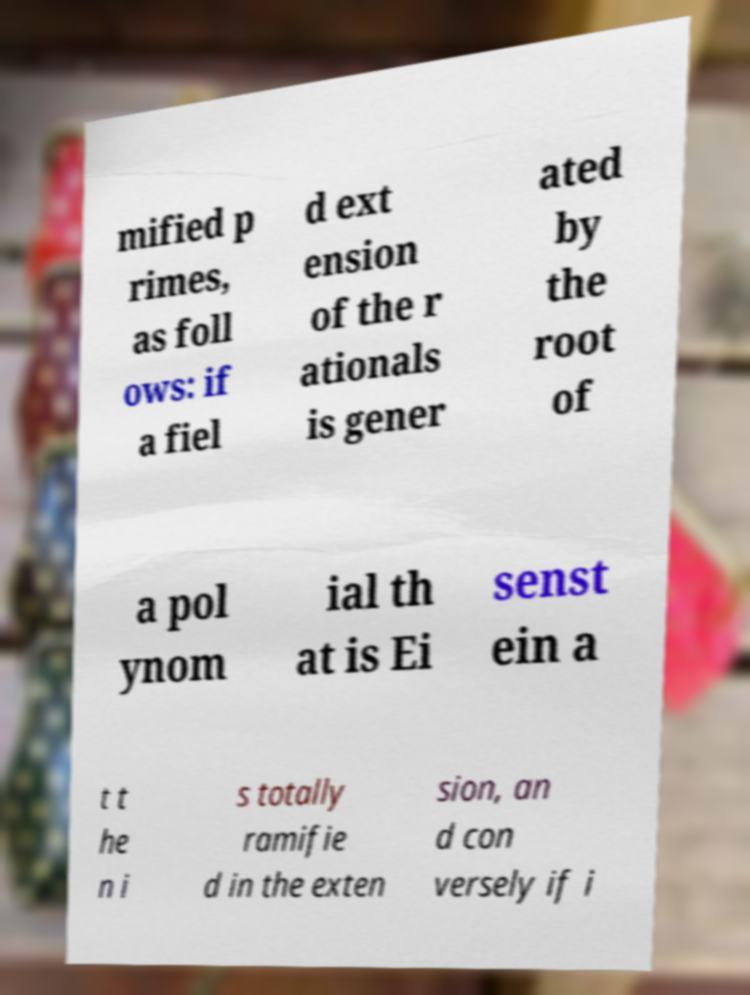What messages or text are displayed in this image? I need them in a readable, typed format. mified p rimes, as foll ows: if a fiel d ext ension of the r ationals is gener ated by the root of a pol ynom ial th at is Ei senst ein a t t he n i s totally ramifie d in the exten sion, an d con versely if i 